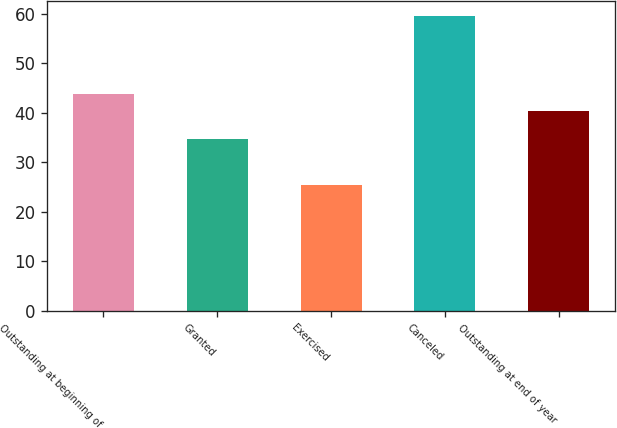Convert chart. <chart><loc_0><loc_0><loc_500><loc_500><bar_chart><fcel>Outstanding at beginning of<fcel>Granted<fcel>Exercised<fcel>Canceled<fcel>Outstanding at end of year<nl><fcel>43.78<fcel>34.67<fcel>25.42<fcel>59.57<fcel>40.37<nl></chart> 